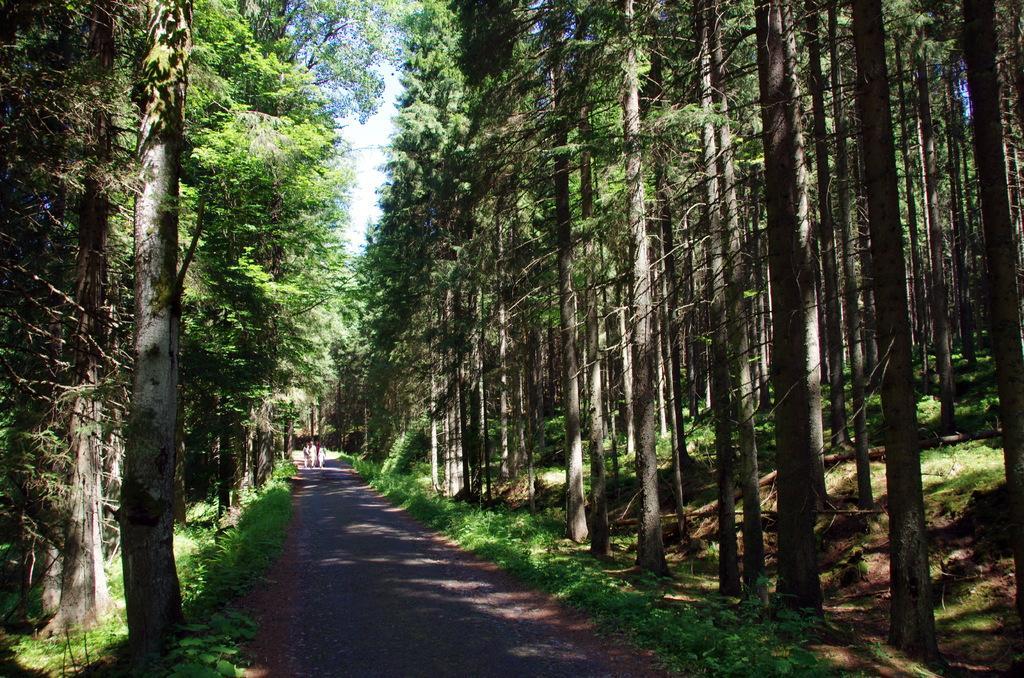How would you summarize this image in a sentence or two? In this picture we can see few people are walking on the road, beside to them we can find few trees. 